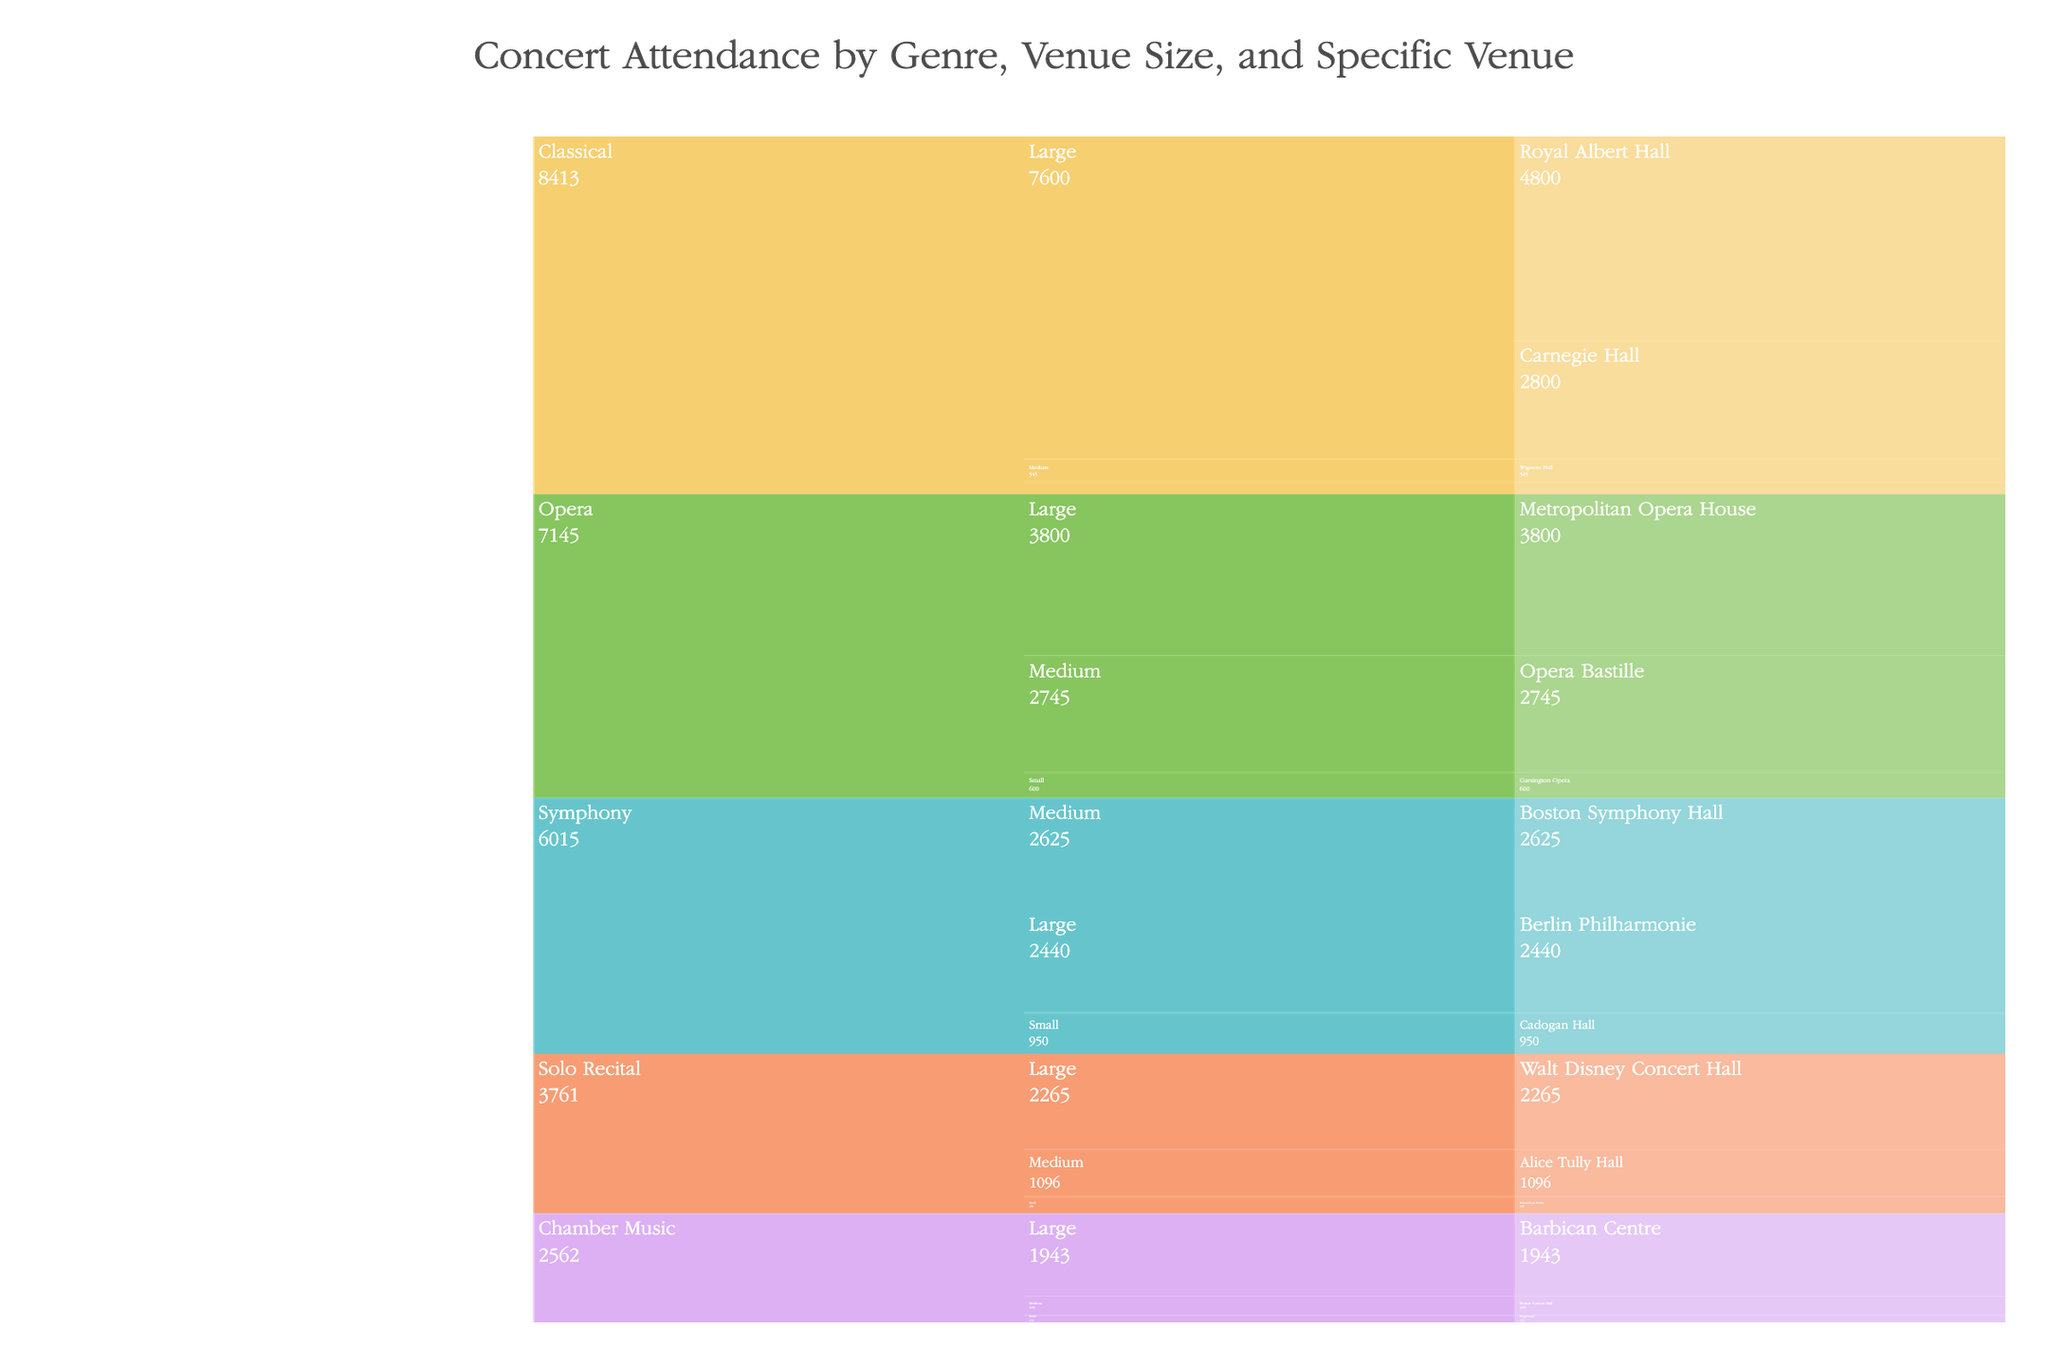what is the venue with the highest attendance for classical genre? The icicle chart groups data by Genre, Venue Size, and Specific Venue. Within the Classical genre, find the venue with the highest attendance.
Answer: Royal Albert Hall Which medium-sized venue has the highest attendance? In the icicle chart, locate the Medium category and compare the attendance numbers across all genres to identify the highest attendance.
Answer: Opera Bastille What is the total attendance for all large venues? Sum the attendance numbers for all Specific Venues under the Large category across all genres.
Answer: 18,248 Which genre has the highest total attendance? Sum the attendance numbers for all Specific Venues within each genre and compare the totals.
Answer: Classical How does the attendance at Wigmore Hall compare to Bargemusic? Identify the attendance numbers for Wigmore Hall and Bargemusic and compare them.
Answer: Wigmore Hall: 545, Bargemusic: 170 What proportion of the total attendance does the Berlin Philharmonie account for? Find the attendance for the Berlin Philharmonie and divide it by the total attendance across all venues. For percentage, multiply by 100.
Answer: Approximately 6.68% Which small venue associated with Symphony has the highest attendance? In the Icicle chart, under the Symphony genre and Small Venue category, find the venue with the highest attendance.
Answer: Cadogan Hall For the genre "Opera," how much greater is the attendance at Metropolitan Opera House compared to Garsington Opera? Subtract the attendance of Garsington Opera from that of Metropolitan Opera House.
Answer: 3,200 Which genre has the smallest number of small-sized venues? Count the number of specific venues under the Small category for each genre.
Answer: Solo Recital What is the difference in attendance between the most popular large venue and the least popular small venue? Identify the most popular large venue and the least popular small venue, and subtract their attendance values.
Answer: 4,630 